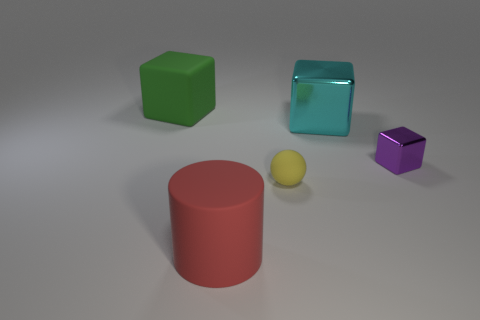What can you infer about the lighting and shadows in this scene? The lighting in the scene appears to be coming from above, casting soft shadows directly under the objects. The positioning and blurriness of the shadows suggest a single diffuse light source, which is consistent with the soft, even illumination on the objects themselves. 